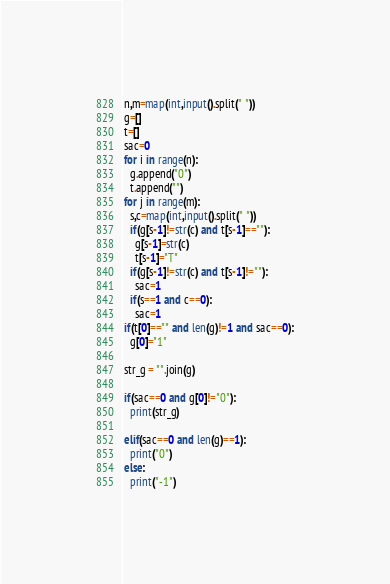Convert code to text. <code><loc_0><loc_0><loc_500><loc_500><_Python_>n,m=map(int,input().split(" "))
g=[]
t=[]
sac=0
for i in range(n):
  g.append("0")
  t.append("")
for j in range(m):
  s,c=map(int,input().split(" "))
  if(g[s-1]!=str(c) and t[s-1]==""):
    g[s-1]=str(c)
    t[s-1]="T"
  if(g[s-1]!=str(c) and t[s-1]!=""):
    sac=1
  if(s==1 and c==0):
    sac=1
if(t[0]=="" and len(g)!=1 and sac==0):
  g[0]="1"

str_g = "".join(g)

if(sac==0 and g[0]!="0"):
  print(str_g)

elif(sac==0 and len(g)==1):
  print("0")
else:
  print("-1")</code> 